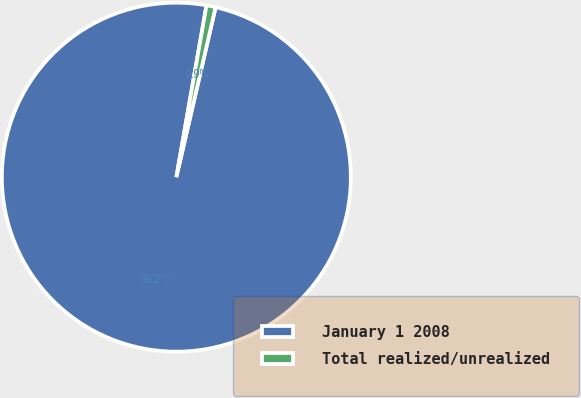Convert chart to OTSL. <chart><loc_0><loc_0><loc_500><loc_500><pie_chart><fcel>January 1 2008<fcel>Total realized/unrealized<nl><fcel>99.15%<fcel>0.85%<nl></chart> 